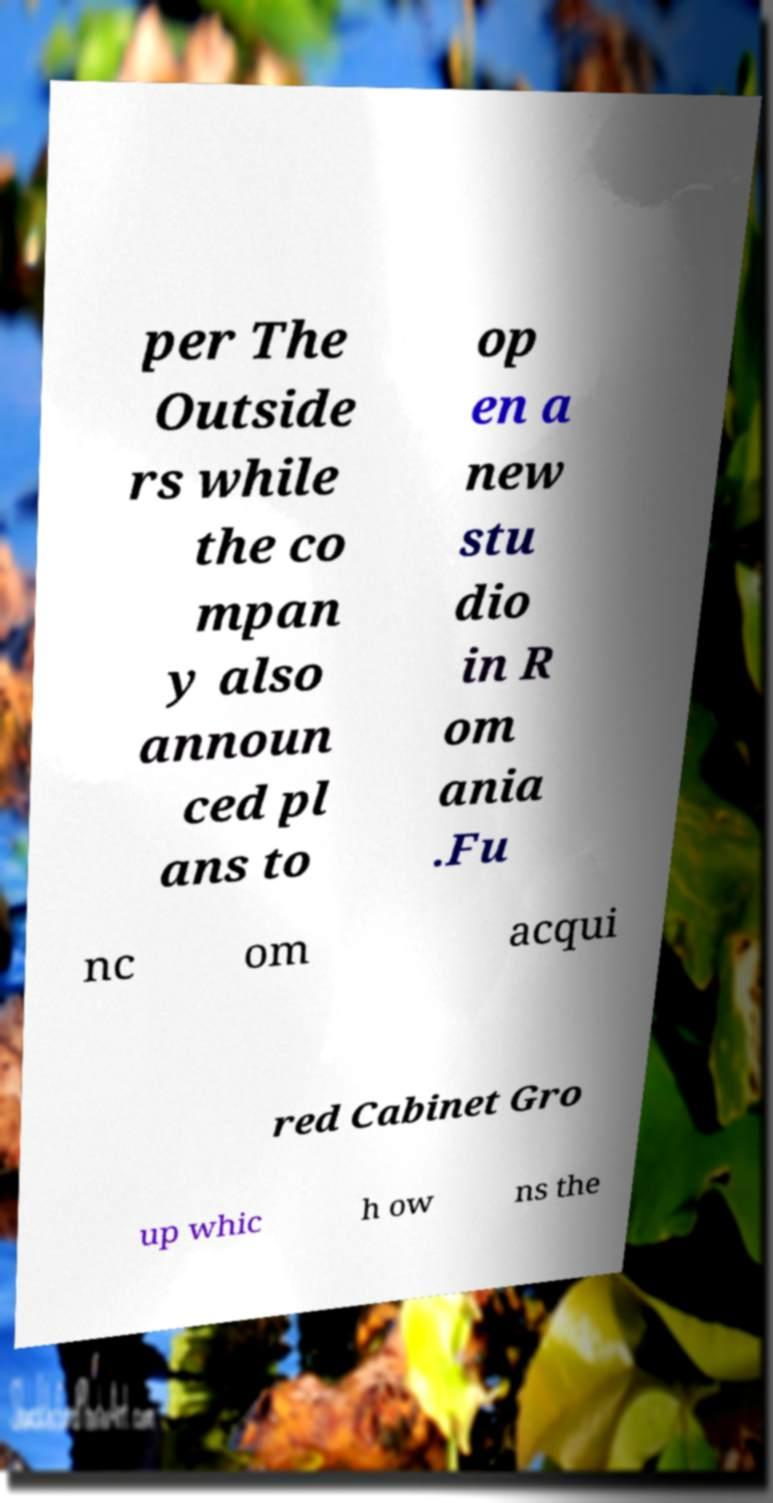For documentation purposes, I need the text within this image transcribed. Could you provide that? per The Outside rs while the co mpan y also announ ced pl ans to op en a new stu dio in R om ania .Fu nc om acqui red Cabinet Gro up whic h ow ns the 